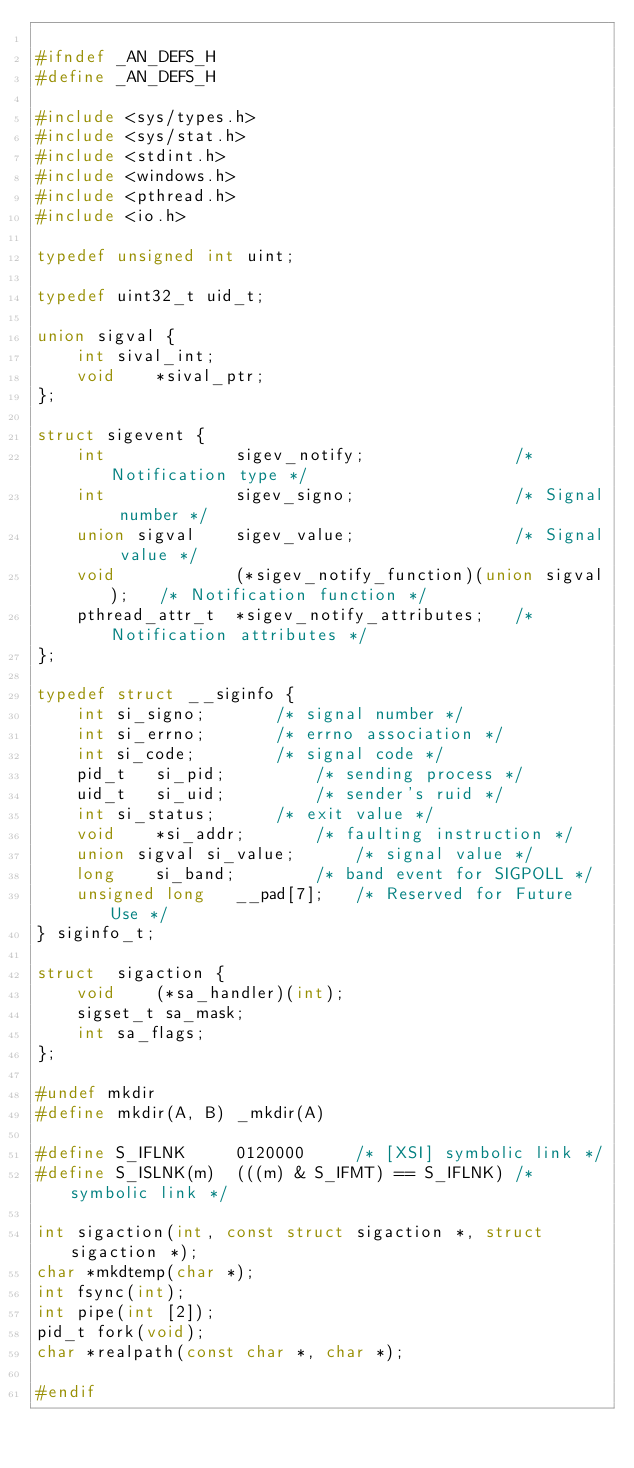<code> <loc_0><loc_0><loc_500><loc_500><_C_>
#ifndef _AN_DEFS_H
#define _AN_DEFS_H

#include <sys/types.h>
#include <sys/stat.h>
#include <stdint.h>
#include <windows.h>
#include <pthread.h>
#include <io.h>

typedef unsigned int uint;

typedef uint32_t uid_t;

union sigval {
	int	sival_int;
	void	*sival_ptr;
};

struct sigevent {
	int				sigev_notify;				/* Notification type */
	int				sigev_signo;				/* Signal number */
	union sigval	sigev_value;				/* Signal value */
	void			(*sigev_notify_function)(union sigval);	  /* Notification function */
	pthread_attr_t	*sigev_notify_attributes;	/* Notification attributes */
};

typedef struct __siginfo {
	int	si_signo;		/* signal number */
	int	si_errno;		/* errno association */
	int	si_code;		/* signal code */
	pid_t	si_pid;			/* sending process */
	uid_t	si_uid;			/* sender's ruid */
	int	si_status;		/* exit value */
	void	*si_addr;		/* faulting instruction */
	union sigval si_value;		/* signal value */
	long	si_band;		/* band event for SIGPOLL */
	unsigned long	__pad[7];	/* Reserved for Future Use */
} siginfo_t;

struct	sigaction {
	void    (*sa_handler)(int);
	sigset_t sa_mask;
	int	sa_flags;
};

#undef mkdir
#define mkdir(A, B) _mkdir(A)

#define	S_IFLNK		0120000		/* [XSI] symbolic link */
#define	S_ISLNK(m)	(((m) & S_IFMT) == S_IFLNK)	/* symbolic link */

int sigaction(int, const struct sigaction *, struct sigaction *);
char *mkdtemp(char *);
int fsync(int);
int pipe(int [2]);
pid_t fork(void);
char *realpath(const char *, char *);

#endif
</code> 